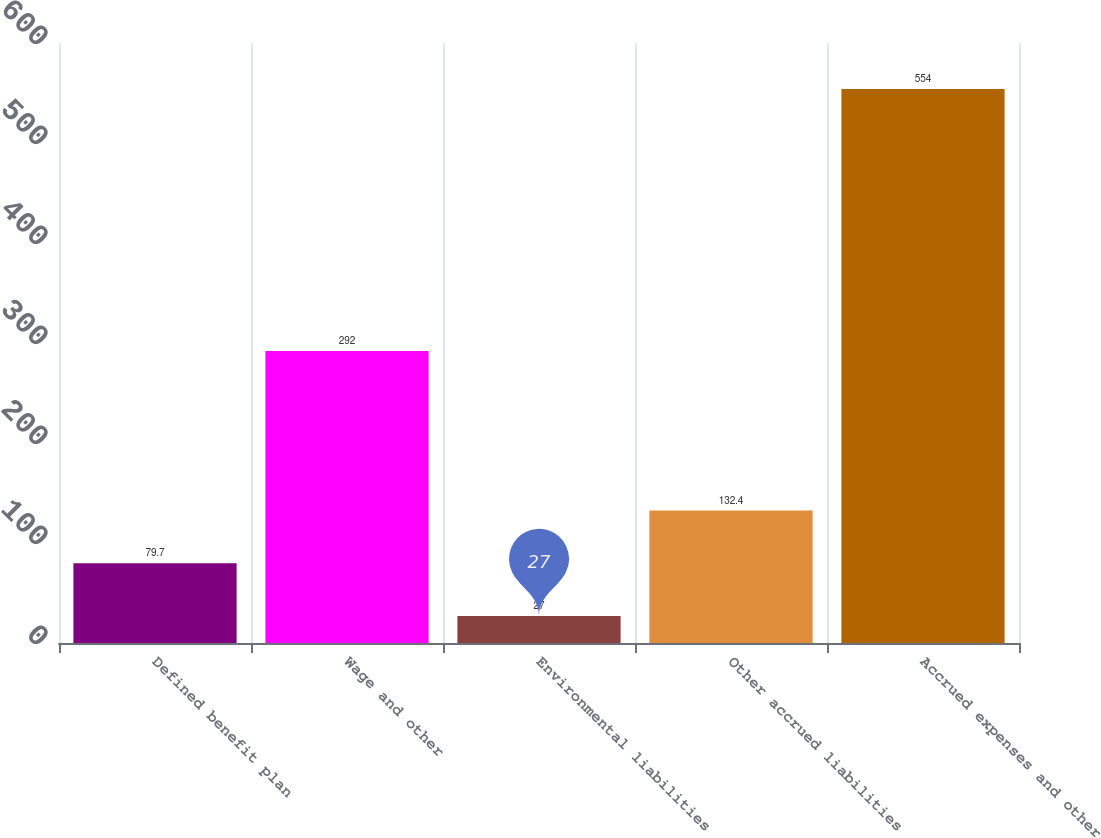Convert chart. <chart><loc_0><loc_0><loc_500><loc_500><bar_chart><fcel>Defined benefit plan<fcel>Wage and other<fcel>Environmental liabilities<fcel>Other accrued liabilities<fcel>Accrued expenses and other<nl><fcel>79.7<fcel>292<fcel>27<fcel>132.4<fcel>554<nl></chart> 